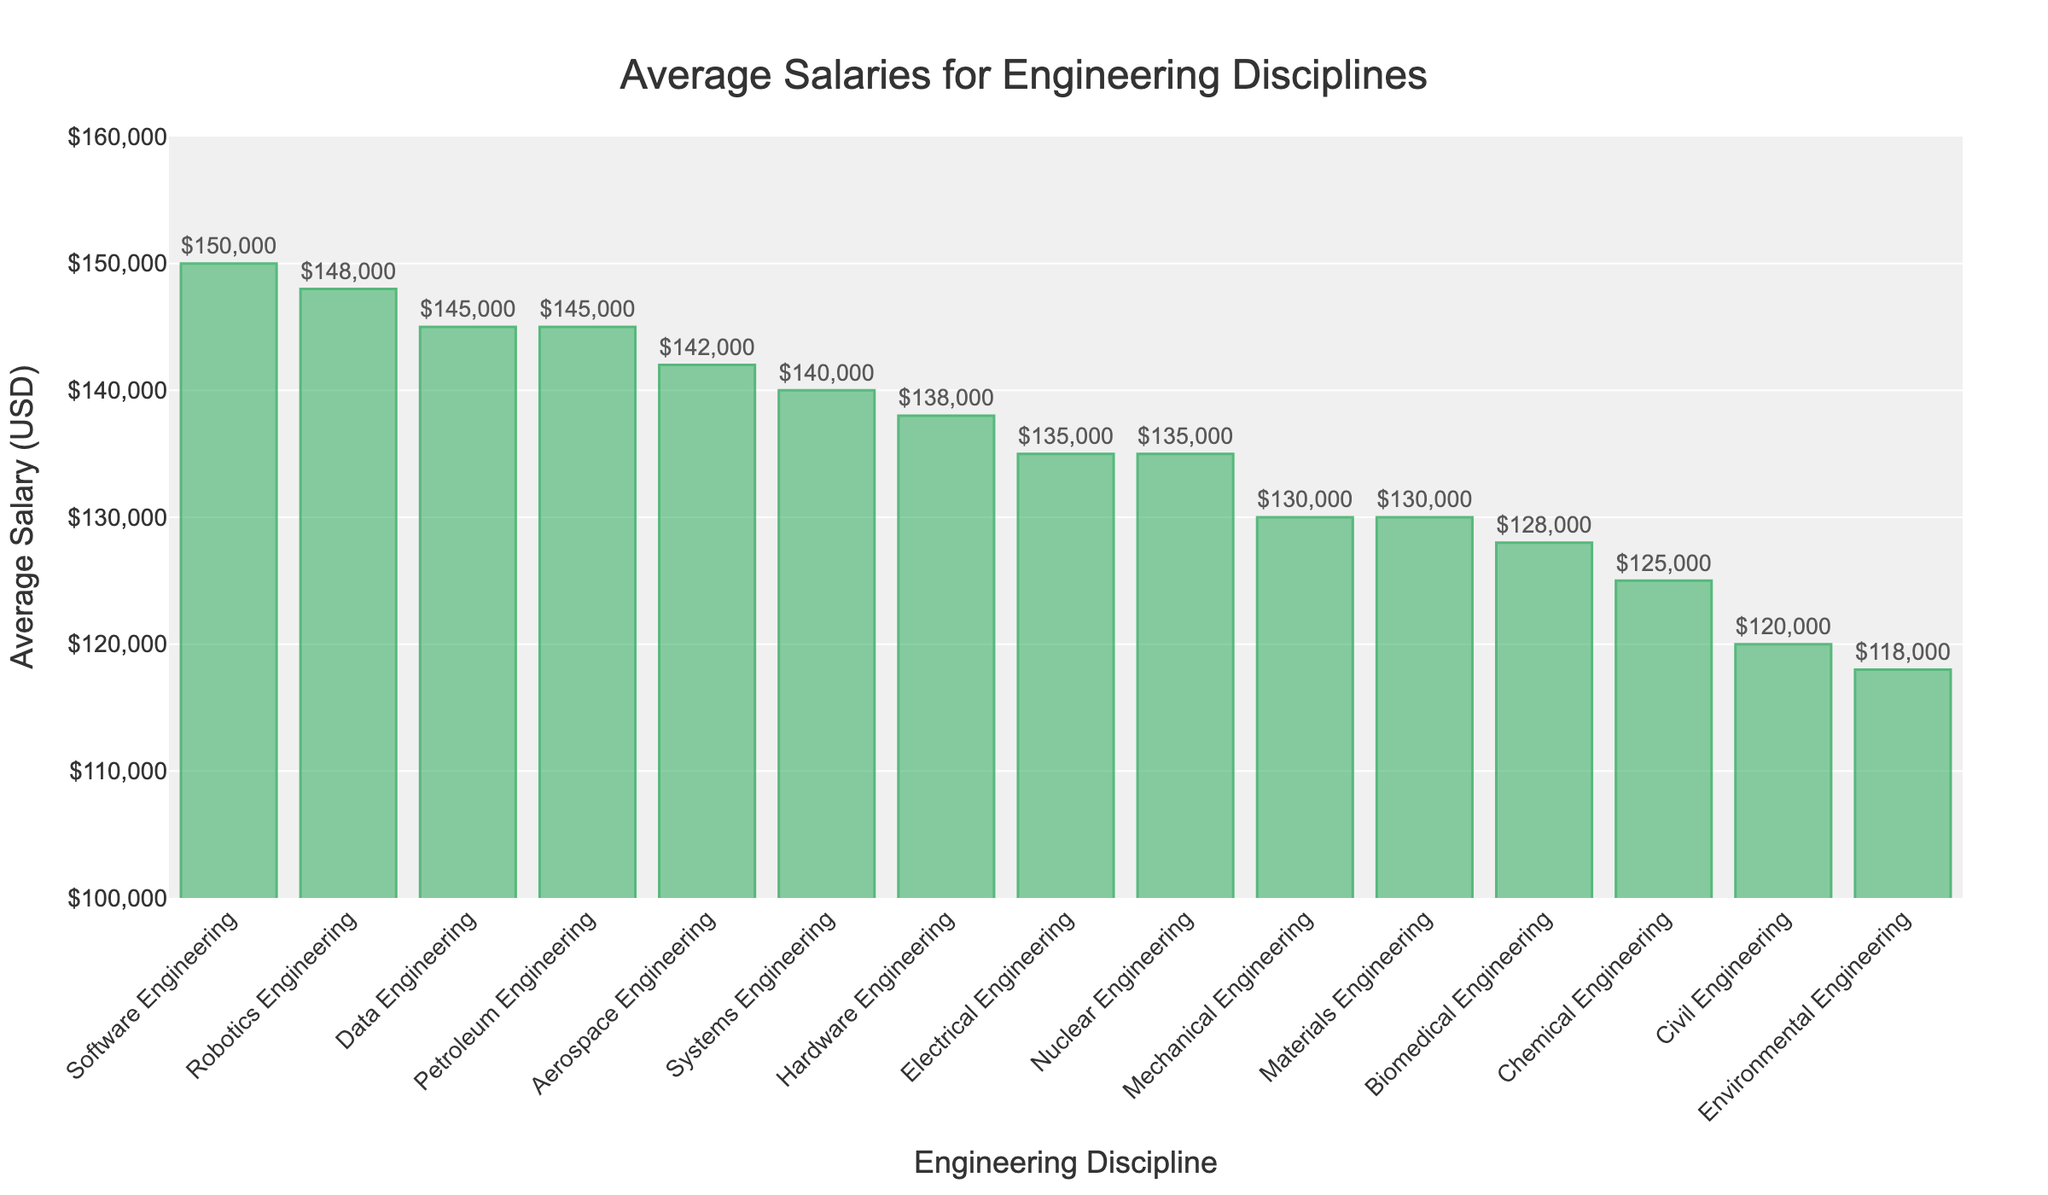Which engineering discipline has the highest average salary? The bar chart sorts the disciplines by average salary in descending order, making it easy to identify the highest. The highest bar represents Software Engineering.
Answer: Software Engineering Which engineering discipline has the lowest average salary? The bar chart sorts the disciplines by average salary in descending order, making it easy to identify the lowest. The lowest bar represents Environmental Engineering.
Answer: Environmental Engineering What is the difference in average salary between Software Engineering and Civil Engineering? Identify the bars for Software Engineering and Civil Engineering, and subtract the latter's average salary from the former's. Software Engineering: $150,000, Civil Engineering: $120,000. The difference is $150,000 - $120,000 = $30,000.
Answer: $30,000 What is the total average salary for Data Engineering and Systems Engineering combined? Identify the bars for Data Engineering and Systems Engineering, and sum their average salaries. Data Engineering: $145,000, Systems Engineering: $140,000. The combined total is $145,000 + $140,000 = $285,000.
Answer: $285,000 Which two engineering disciplines have the closest average salaries? Look for pairs of bars that have nearly the same height. Hardware Engineering and Nuclear Engineering both have an average salary of $135,000.
Answer: Electrical Engineering and Nuclear Engineering Does Biomedical Engineering have a higher or lower average salary than Mechanical Engineering? Compare the height of the bar for Biomedical Engineering with that for Mechanical Engineering. Biomedical Engineering's bar is shorter than Mechanical Engineering's.
Answer: Lower By how much does the average salary of Robotics Engineering exceed that of Chemical Engineering? Identify the bars for Robotics Engineering and Chemical Engineering, and subtract the latter's average salary from the former's. Robotics Engineering: $148,000, Chemical Engineering: $125,000. The difference is $148,000 - $125,000 = $23,000.
Answer: $23,000 Which three engineering disciplines have the highest average salaries? Identify the three tallest bars from the top down. They represent Software Engineering, Robotics Engineering, and Data Engineering.
Answer: Software Engineering, Robotics Engineering, Data Engineering What is the average salary for Aerospace Engineering, Materials Engineering, and Biomedical Engineering combined? Identify the bars for Aerospace Engineering, Materials Engineering, and Biomedical Engineering, and sum their average salaries. Aerospace Engineering: $142,000, Materials Engineering: $130,000, Biomedical Engineering: $128,000. The combined total is $142,000 + $130,000 + $128,000 = $400,000. Then divide by 3: $400,000 / 3 = $133,333.33.
Answer: $133,333.33 How many disciplines have an average salary greater than $140,000? Count the number of bars whose height corresponds to an average salary above $140,000. These include Software Engineering, Data Engineering, Robotics Engineering, and Aerospace Engineering.
Answer: 4 